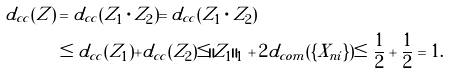<formula> <loc_0><loc_0><loc_500><loc_500>d _ { c c } ( Z ) & = d _ { c c } ( Z _ { 1 } \cdot Z _ { 2 } ) = d _ { c c } ( Z _ { 1 } \cdot Z _ { 2 } ) \\ & \leq d _ { c c } ( Z _ { 1 } ) + d _ { c c } ( Z _ { 2 } ) \leq \| Z _ { 1 } \| _ { 1 } + 2 d _ { c o m } ( \{ X _ { n i } \} ) \leq \frac { 1 } { 2 } + \frac { 1 } { 2 } = 1 .</formula> 